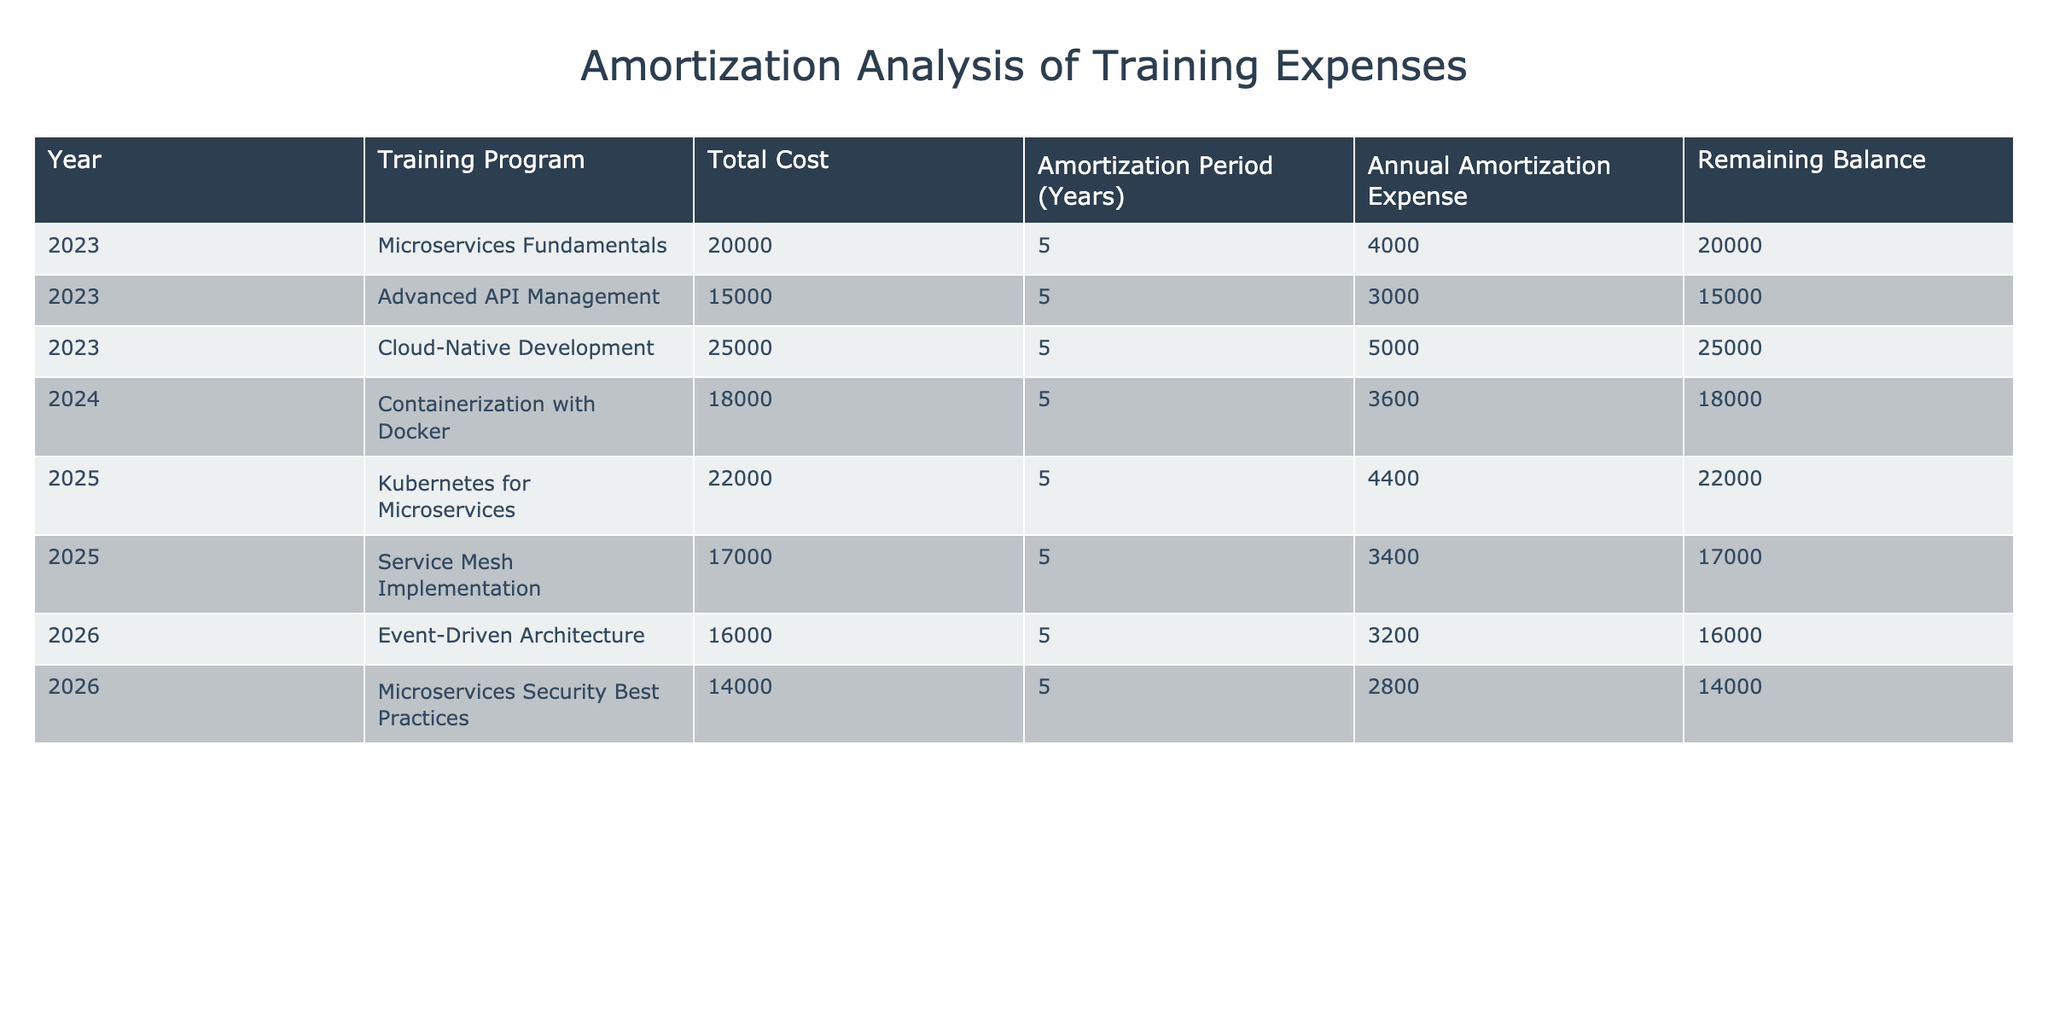What is the total cost of the training program "Microservices Fundamentals"? The total cost of the training program "Microservices Fundamentals" is directly listed under the "Total Cost" column next to the year 2023 in the table. It states that the cost is 20000.
Answer: 20000 What is the remaining balance for "Kubernetes for Microservices" after its first year? The table indicates that the remaining balance after the first year for "Kubernetes for Microservices," which has a total cost of 22000, remains 22000, as no amortization expense has been applied in the same year.
Answer: 22000 What is the average annual amortization expense for all training programs listed? To find the average, first sum all the annual amortization expenses: 4000 + 3000 + 5000 + 3600 + 4400 + 3400 + 3200 + 2800 = 29,400. There are 8 programs, so the average is 29,400 / 8 = 3675.
Answer: 3675 Is the amortization period for all the training programs the same? Yes, a quick look at the "Amortization Period (Years)" column shows that all training programs have the same amortization period of 5 years.
Answer: Yes What is the total cost of all training programs combined for the year 2023? For 2023, add the total costs of all training programs listed in that year: 20000 (Microservices Fundamentals) + 15000 (Advanced API Management) + 25000 (Cloud-Native Development) = 60000.
Answer: 60000 What is the remaining balance for "Service Mesh Implementation" in 2026? To find the remaining balance in 2026, we consider that in 2025, the balance was 17000 before application of amortization. One year's amortization (3400) then brings the remaining balance for "Service Mesh Implementation" down to 13600 in 2026.
Answer: 13600 Which training program has the highest annual amortization expense and what is that amount? By scanning the "Annual Amortization Expense" column, "Cloud-Native Development" has the highest expense listed at 5000.
Answer: 5000 How much total training expense will be amortized over the entire amortization period for all training programs? The total expense to be amortized can be calculated by multiplying the annual amortization expense for each program by the amortization period (5 years) and summing it all up: (4000 + 3000 + 5000 + 3600 + 4400 + 3400 + 3200 + 2800) * 5 = 147000.
Answer: 147000 